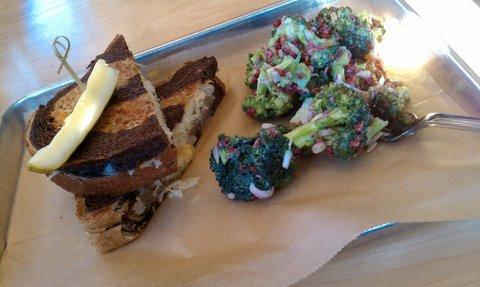In a poetic manner, describe the things placed on the tray. Upon a silvery tray, lies a feast of colors and textures; a verdant world of broccoli and onions, a savory sandwich with a tangy pickle, and a delightful cake, all waiting to be consumed. State your thoughts on the quality of the food presented and whether they would be enjoyable to consume. The food on the tray appears fresh, vibrant, and appetizing, which suggests they would be enjoyable to consume. Count the number of vegetables present in the image and list them. There are four vegetables visible - broccoli (in two locations), red peppers, onions, and a pickle slice. Express the image's general ambiance in one sentence. The assortment of appetizing food on the tray evokes a cozy and inviting atmosphere. Describe the interaction between the sandwich and other objects in the image. The sandwich interacts with a pickle slice on top and is held together by a toothpick, while it rests upon a metal tray lined with wax paper. What are the primary food items on the tray and their corresponding garnishes or toppings? Primary food items include the sandwich with a pickle slice, the broccoli salad with red peppers, and the cake; each intricately adorned and ready to be savored. Identify three food items in the image, and describe their distinct colors. A multi-colored bread sandwich, a green pickle slice, and a brown cake are shown in the picture. Enumerate the objects that are in direct contact with the metal tray. A sandwich, wax paper, broccoli, onions, fork, and spoon are in direct contact with the metal tray. Mention the elements present in the portrayed cafeteria scene. A sandwich, pickle, fork, spoon, celery, cake, broccoli, red peppers, onions, toothpick, wax paper, metal tray, wooden table, and light reflection are all present. Analyze the objects found on the wooden table and their placement. A metal tray holding a variety of food items and utensils is placed centrally on the wooden table, with some light reflecting onto the table's surface. Which of these options is placed on the tray - fork, spoon, toothpick or knife? Fork and spoon. Is there a chocolate ice cream in the image? There is no mention of chocolate ice cream in the image. It says there is some ice cream, but its colors are not specified. This question is misleading because it assumes that the ice cream is chocolate flavored when it's not explicitly mentioned. Can you find the red-colored pickle in the image? There is no red-colored pickle in the image; there is only a pale green pickle slice, which is misleading because the actual color of the pickle is mentioned as green. Write a caption for the image highlighting the placement of items on the tray. A metal fork and spoon, a sandwich with multi-colored bread, and a salad with broccoli and onions are placed on a silver metal tray. What type of toothpick is sticking in the sandwich? Plastic spear toothpick. Is there a ceramic spoon in the image? There is no mention of a ceramic spoon in the image. There is a spoon, but it is referred to as shiny or metallic, which implies it is not ceramic. This question is misleading because it assumes the presence of a ceramic spoon when none is described. Describe the object that appears shiny in the image. A stainless steel utensil handle is shiny. Describe the paper placed on the tray. A brown wax paper liner is on top of the tray. Is there a wooden tray in the image? There is no mention of a wooden tray in the image. There is a silver metal tray, a silvery tray, and a cafeteria tray described. This question is misleading because it assumes the presence of a wooden tray when all trays mentioned are metallic. Is there any ice cream in the image? If so, describe its appearance. Yes, the ice cream has several colors. How is the light reflecting on the table in the image? There is a reflection of light on the table. Can you see the blue-colored toothpick? There is no mention of a blue-colored toothpick in the image. There is a plastic spear toothpick (without specified color). This question is misleading because it expects the reader to find a blue toothpick that does not exist in the image. Analyze and describe the object interactions happening in this image. A sandwich with pickle slice and a toothpick holding it together, a salad with chopped broccoli and red onions, and eating utensils including a fork and a spoon, are on top of a tray that is placed on a wooden table. Is the broccoli on the tray presented as a whole or chopped? Chopped green broccoli floret. Which type of table is present in the image? A tan wooden table. Identify the item placed on top of the sandwich and describe its color. A pale green pickle slice is on top of the sandwich. Mention the vegetables present on the tray with their specific colors. Green broccoli, red peppers, and red onions. What objects are holding the sandwich together in the image? A toothpick is holding the sandwich together. What is the color and texture of the broccoli in the image? The broccoli is green and creamy in texture. Can you spot the orange-colored onions? There are no orange-colored onions in the image. The image mentions chopped red onion. This question is misleading because it expects the reader to find orange onions when only red onions are mentioned. Is the cake sliced in the image? Yes, the cake is sliced. What lies between the sandwich and the tray? A white piece of wax paper. What is the shape and color of the sandwich's bread in the image? The bread is multi-colored and is marble rye. How are the bacon crumbles presented in the image? Bits of bacon crumbles are present. What material is the spoon made up of? The spoon is metallic and shiny. What activities can be recognized in the image? Sandwich assembly, salad preparation, table setting, and light reflection. 